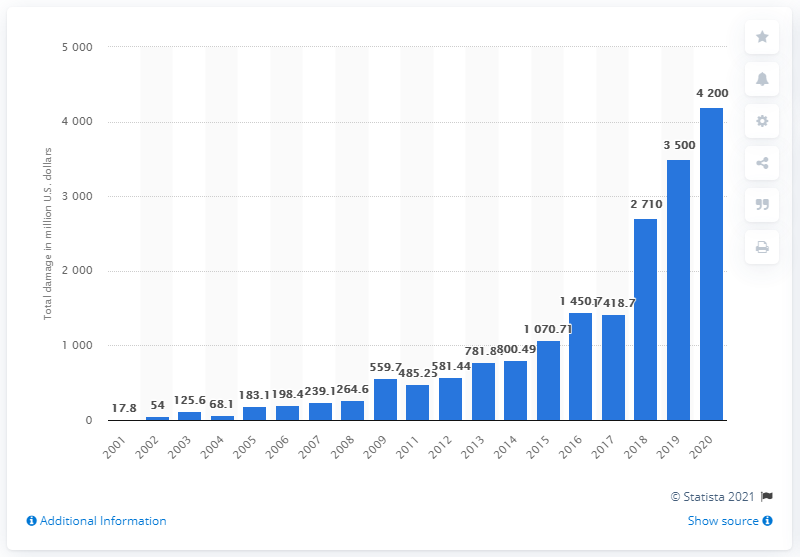Highlight a few significant elements in this photo. The annual loss of complaints referred to the IC3 was approximately 4,200. 